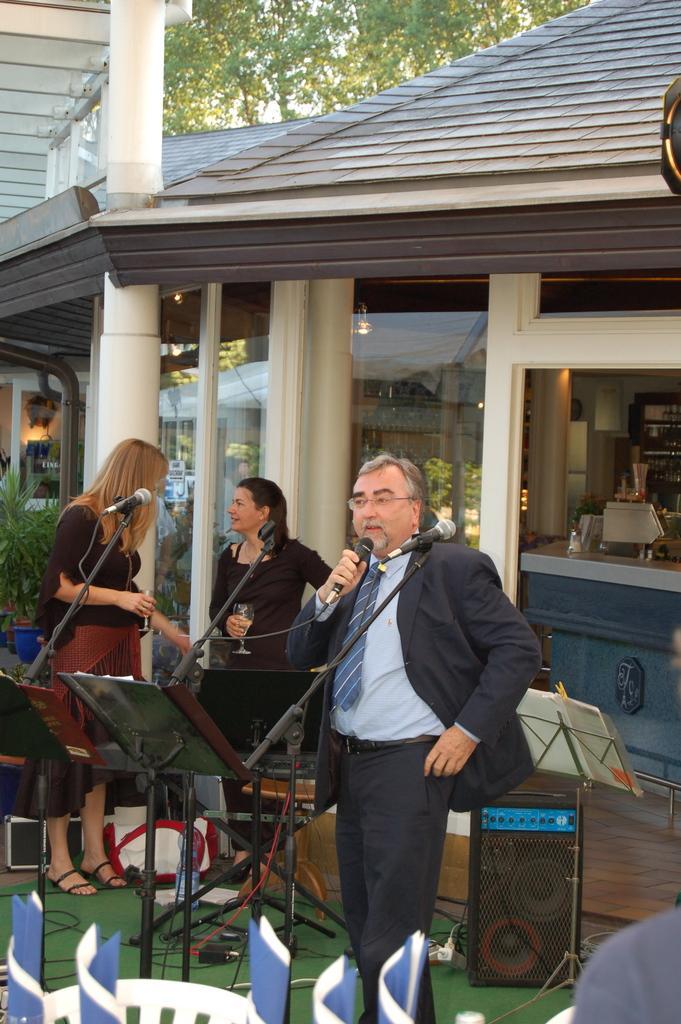Describe this image in one or two sentences. This is an outside view. Here I can see a man standing facing towards the left side, holding a mike in the hand and speaking. Beside him there are metal stands. At the back there are two women holding glasses in their hands, standing and looking at each other. Here I can see a speaker and few cables on the ground. At the bottom of the image there are few papers and a chair. In the background there is a building. At the top of the image there is a tree. 